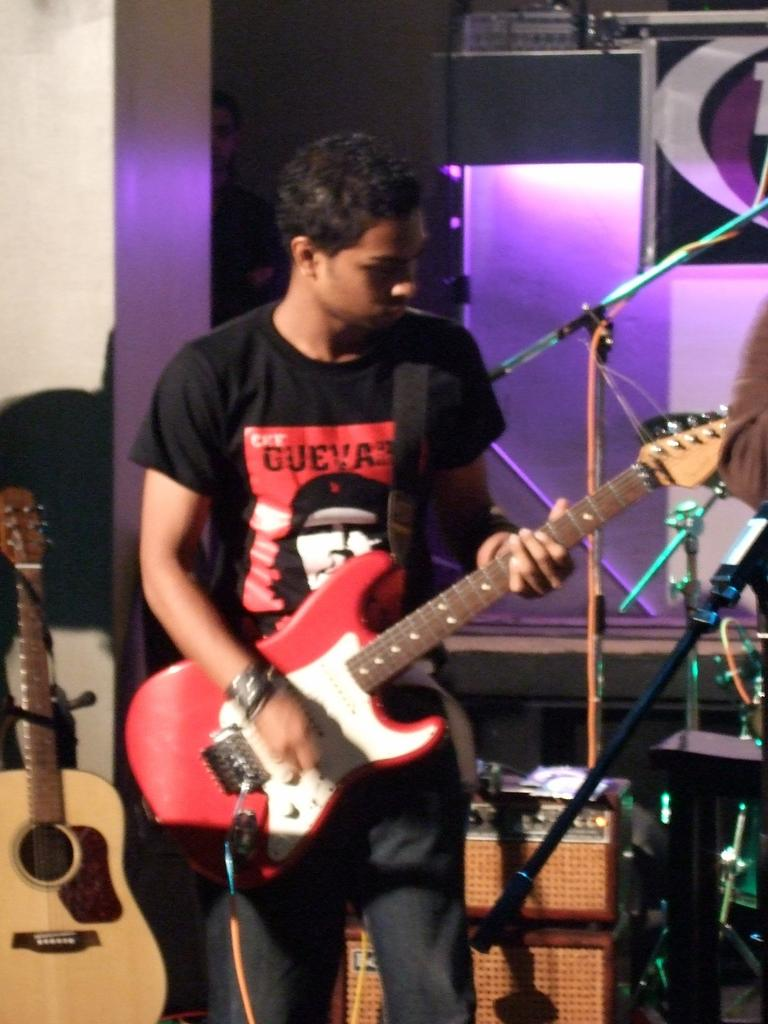What is the man in the image doing? The man is playing a guitar in the image. What object is in front of the man? There is a microphone in front of the man. What can be seen in the background of the image? There are lights and musical instruments visible in the background of the image. What type of chalk is the man using to write on the whip in the image? There is no chalk or whip present in the image; the man is playing a guitar and there is a microphone in front of him. 